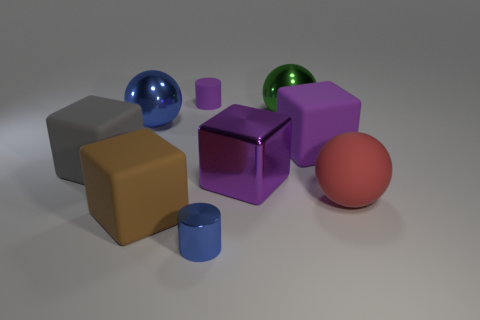Subtract all gray cubes. How many cubes are left? 3 Add 1 big matte spheres. How many objects exist? 10 Subtract all balls. How many objects are left? 6 Subtract all metallic balls. Subtract all large yellow objects. How many objects are left? 7 Add 5 gray cubes. How many gray cubes are left? 6 Add 5 tiny cylinders. How many tiny cylinders exist? 7 Subtract 0 yellow cubes. How many objects are left? 9 